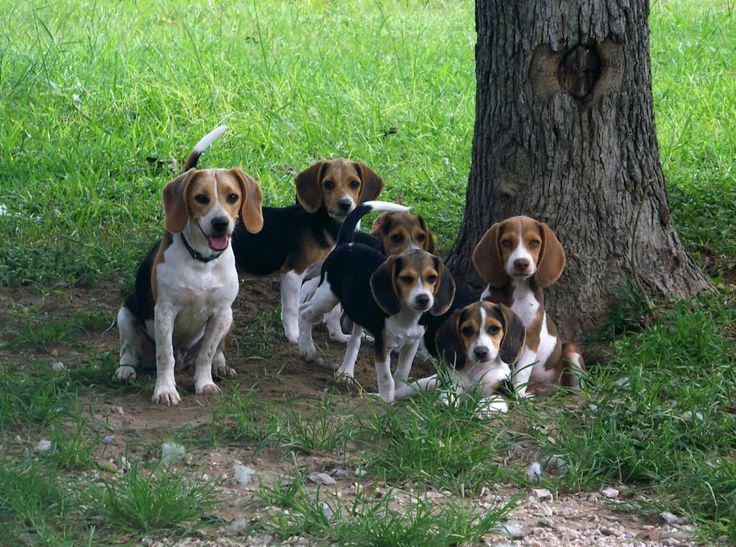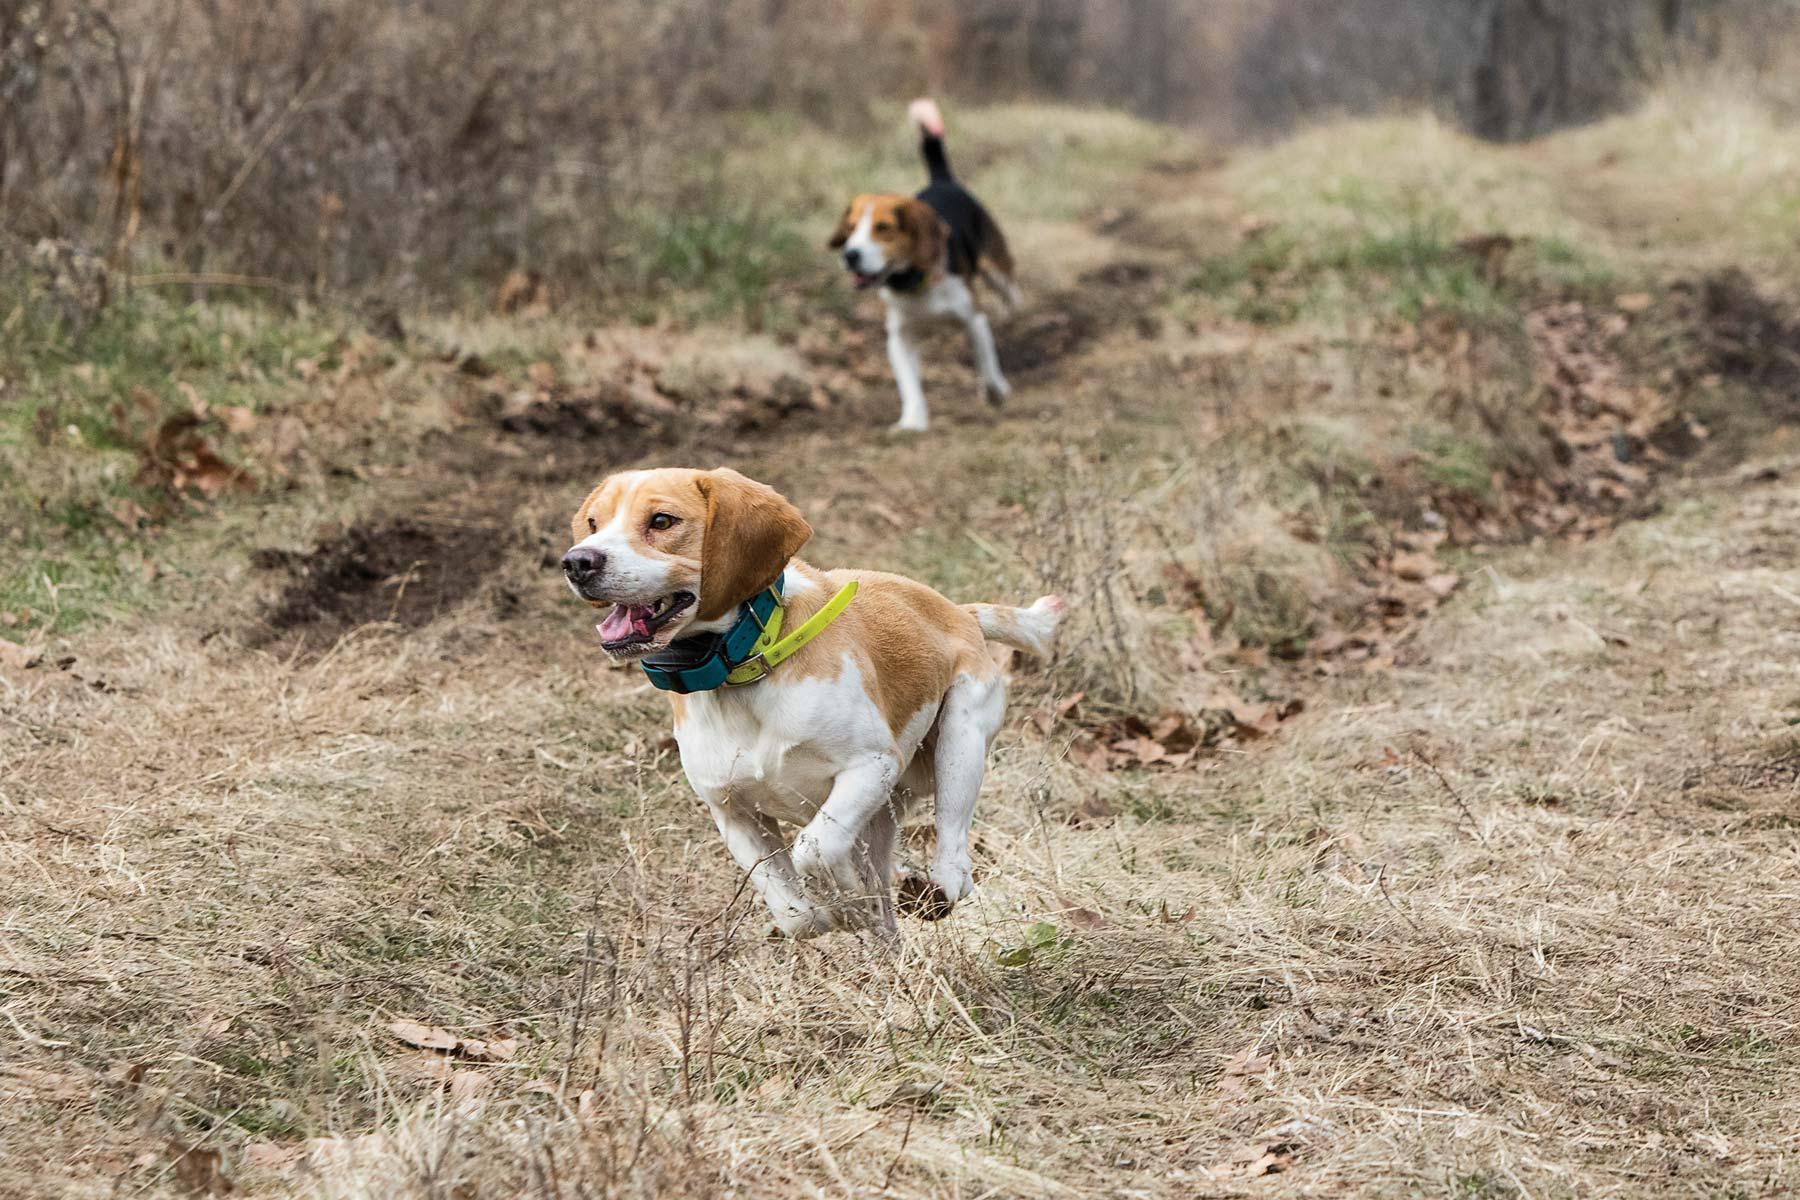The first image is the image on the left, the second image is the image on the right. Analyze the images presented: Is the assertion "There is exactly one dog in one of the images." valid? Answer yes or no. No. 